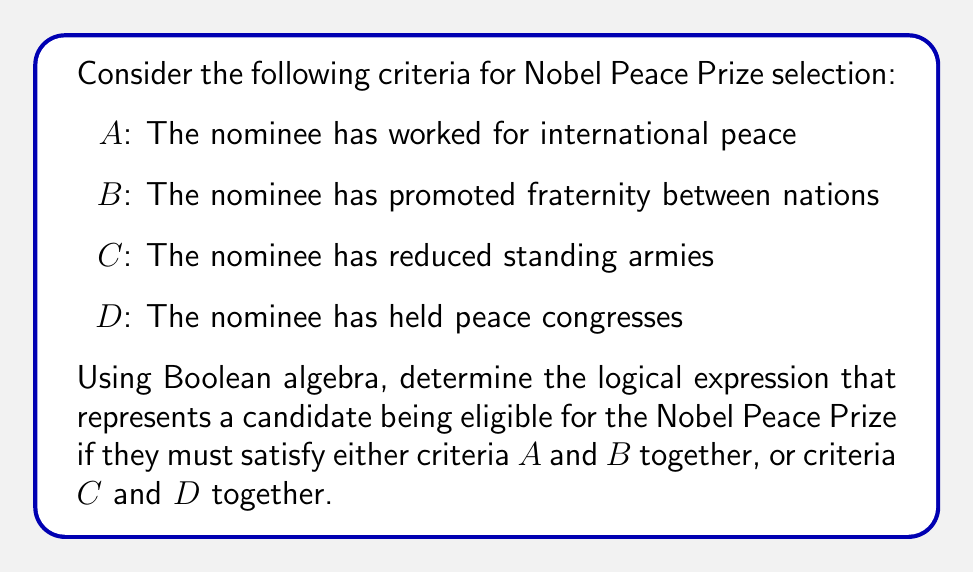What is the answer to this math problem? Let's approach this step-by-step using Boolean algebra:

1) We need to represent two possible combinations:
   - Criteria A and B together
   - Criteria C and D together

2) For criteria A and B together, we use the AND operation (∧):
   $A \wedge B$

3) For criteria C and D together, we also use the AND operation:
   $C \wedge D$

4) Since a candidate needs to satisfy either the first combination OR the second, we use the OR operation (∨) to connect these two expressions:

   $(A \wedge B) \vee (C \wedge D)$

5) This logical expression represents the conditions for a candidate to be eligible for the Nobel Peace Prize according to the given criteria.

6) In Boolean algebra, this expression cannot be simplified further without additional information about the relationships between A, B, C, and D.

Therefore, the final logical expression for Nobel Peace Prize eligibility based on the given criteria is:

$$(A \wedge B) \vee (C \wedge D)$$

This expression reads as: "A candidate is eligible if they satisfy (A and B) or (C and D)."
Answer: $(A \wedge B) \vee (C \wedge D)$ 